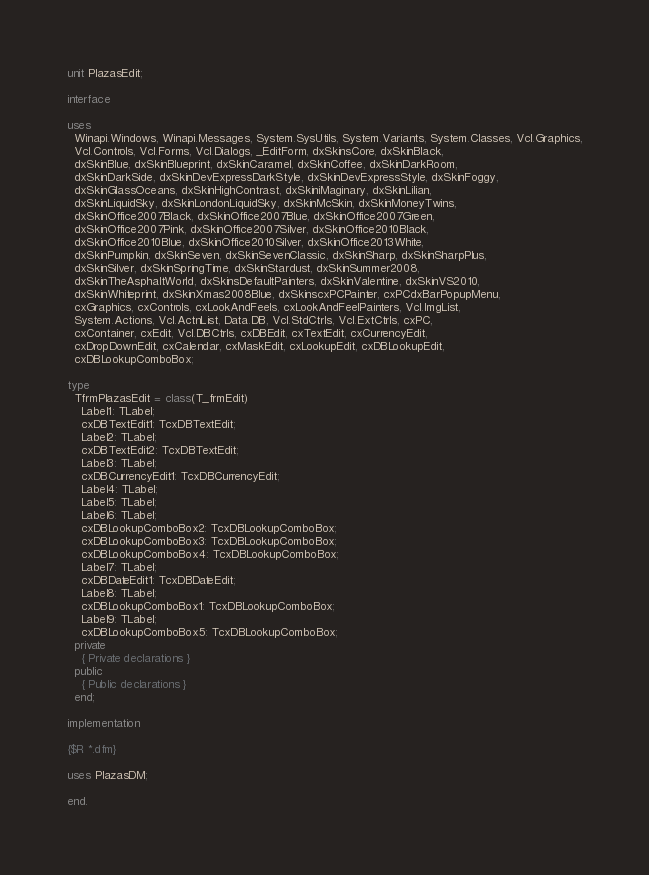<code> <loc_0><loc_0><loc_500><loc_500><_Pascal_>unit PlazasEdit;

interface

uses
  Winapi.Windows, Winapi.Messages, System.SysUtils, System.Variants, System.Classes, Vcl.Graphics,
  Vcl.Controls, Vcl.Forms, Vcl.Dialogs, _EditForm, dxSkinsCore, dxSkinBlack,
  dxSkinBlue, dxSkinBlueprint, dxSkinCaramel, dxSkinCoffee, dxSkinDarkRoom,
  dxSkinDarkSide, dxSkinDevExpressDarkStyle, dxSkinDevExpressStyle, dxSkinFoggy,
  dxSkinGlassOceans, dxSkinHighContrast, dxSkiniMaginary, dxSkinLilian,
  dxSkinLiquidSky, dxSkinLondonLiquidSky, dxSkinMcSkin, dxSkinMoneyTwins,
  dxSkinOffice2007Black, dxSkinOffice2007Blue, dxSkinOffice2007Green,
  dxSkinOffice2007Pink, dxSkinOffice2007Silver, dxSkinOffice2010Black,
  dxSkinOffice2010Blue, dxSkinOffice2010Silver, dxSkinOffice2013White,
  dxSkinPumpkin, dxSkinSeven, dxSkinSevenClassic, dxSkinSharp, dxSkinSharpPlus,
  dxSkinSilver, dxSkinSpringTime, dxSkinStardust, dxSkinSummer2008,
  dxSkinTheAsphaltWorld, dxSkinsDefaultPainters, dxSkinValentine, dxSkinVS2010,
  dxSkinWhiteprint, dxSkinXmas2008Blue, dxSkinscxPCPainter, cxPCdxBarPopupMenu,
  cxGraphics, cxControls, cxLookAndFeels, cxLookAndFeelPainters, Vcl.ImgList,
  System.Actions, Vcl.ActnList, Data.DB, Vcl.StdCtrls, Vcl.ExtCtrls, cxPC,
  cxContainer, cxEdit, Vcl.DBCtrls, cxDBEdit, cxTextEdit, cxCurrencyEdit,
  cxDropDownEdit, cxCalendar, cxMaskEdit, cxLookupEdit, cxDBLookupEdit,
  cxDBLookupComboBox;

type
  TfrmPlazasEdit = class(T_frmEdit)
    Label1: TLabel;
    cxDBTextEdit1: TcxDBTextEdit;
    Label2: TLabel;
    cxDBTextEdit2: TcxDBTextEdit;
    Label3: TLabel;
    cxDBCurrencyEdit1: TcxDBCurrencyEdit;
    Label4: TLabel;
    Label5: TLabel;
    Label6: TLabel;
    cxDBLookupComboBox2: TcxDBLookupComboBox;
    cxDBLookupComboBox3: TcxDBLookupComboBox;
    cxDBLookupComboBox4: TcxDBLookupComboBox;
    Label7: TLabel;
    cxDBDateEdit1: TcxDBDateEdit;
    Label8: TLabel;
    cxDBLookupComboBox1: TcxDBLookupComboBox;
    Label9: TLabel;
    cxDBLookupComboBox5: TcxDBLookupComboBox;
  private
    { Private declarations }
  public
    { Public declarations }
  end;

implementation

{$R *.dfm}

uses PlazasDM;

end.
</code> 